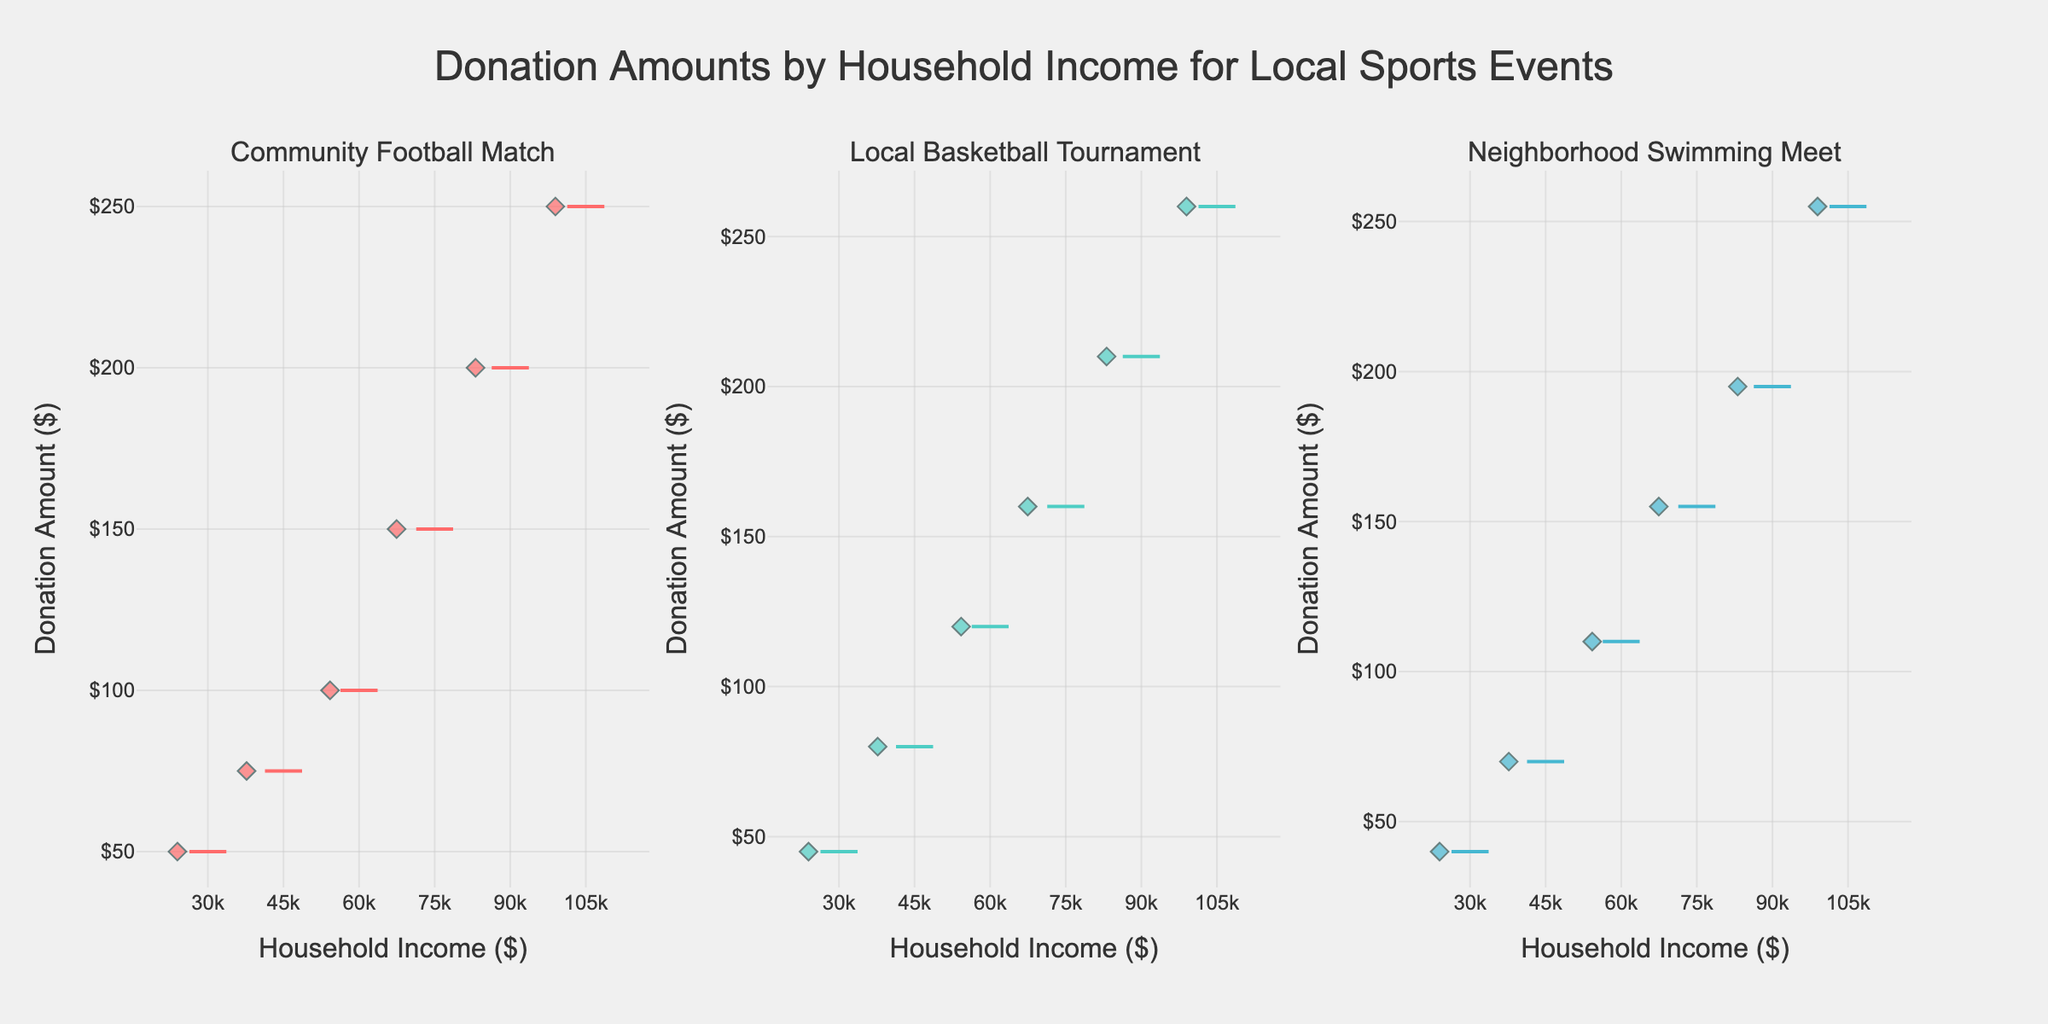What is the title of the figure? The title is typically at the top of the figure. It gives viewers an overview of what the figure is about.
Answer: Donation Amounts by Household Income for Local Sports Events How many subplots are in the figure? The figure consists of multiple box plots organized in subplots. By visually counting them, we can see there are three subplots.
Answer: Three Which event had the highest max donation amount? To find the highest max donation, we need to look for the box plot with the highest whisker or outlier in each subplot. The subplot with the highest value is the Local Basketball Tournament.
Answer: Local Basketball Tournament What is the median donation for Community Football Match? The median of the box plot is indicated by the line in the middle of the box. In the Community Football Match subplot, the median appears to align with the middle value.
Answer: $125 How does the median donation for Neighborhood Swimming Meet compare with Community Football Match? Comparing the medians, the median donation for Neighborhood Swimming Meet is slightly lower than that for the Community Football Match.
Answer: Lower What household income range donates the most on average in the Local Basketball Tournament? By examining the box plot, the longest middle box or the position of the whiskers generally gives an indication of higher donations. The highest income range of $105k generally donates the most.
Answer: $105k Are there any outliers in the $30k-$45k income range for the Community Football Match? Outliers in a box plot are usually marked by points beyond the whiskers. In this specific income range for Community Football Match, no separate points indicate outliers.
Answer: No Which event shows the widest range of donation amounts? The range in a box plot is the distance between the lowest and highest points (whiskers). By comparing, the Local Basketball Tournament shows the widest range.
Answer: Local Basketball Tournament Is there a trend between household income and donation amount across all events? All box plots should be examined to see if donation amounts increase consistently with household incomes. All show this positive correlation.
Answer: Yes 